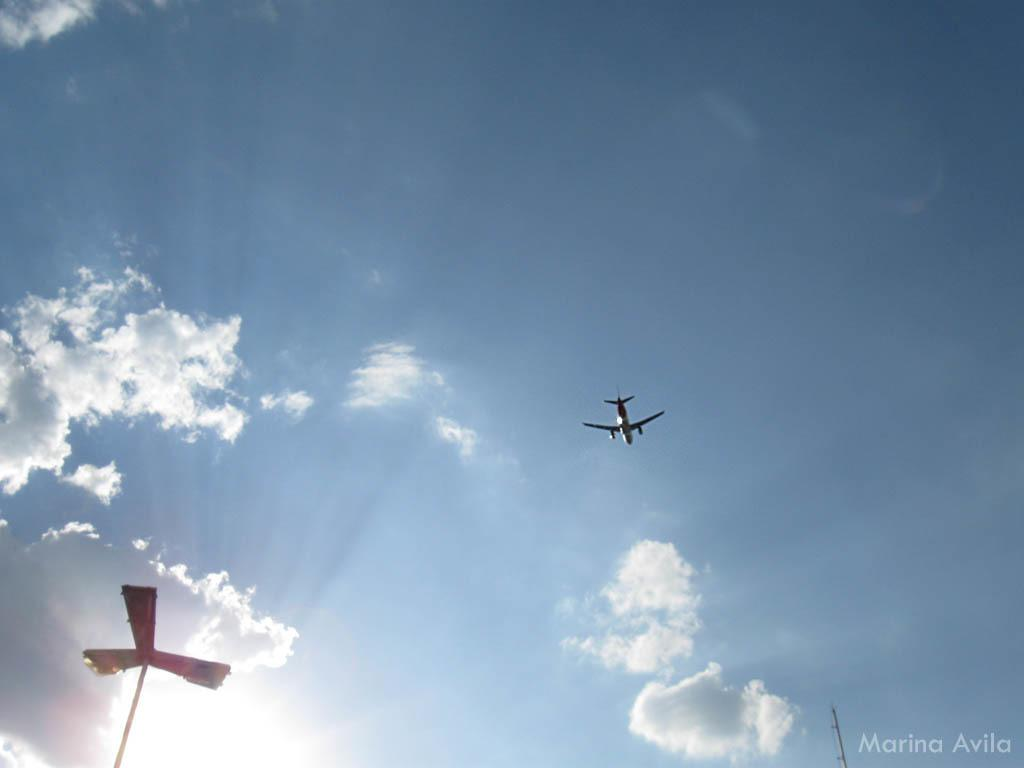What is located on the left side of the image? There is a pole on the left side of the image. What can be seen in the sky in the center of the image? There is an aeroplane flying in the sky in the center of the image. Who is the creator of the summer range in the image? There is no reference to a creator, summer, or range in the image, so this question cannot be answered. 